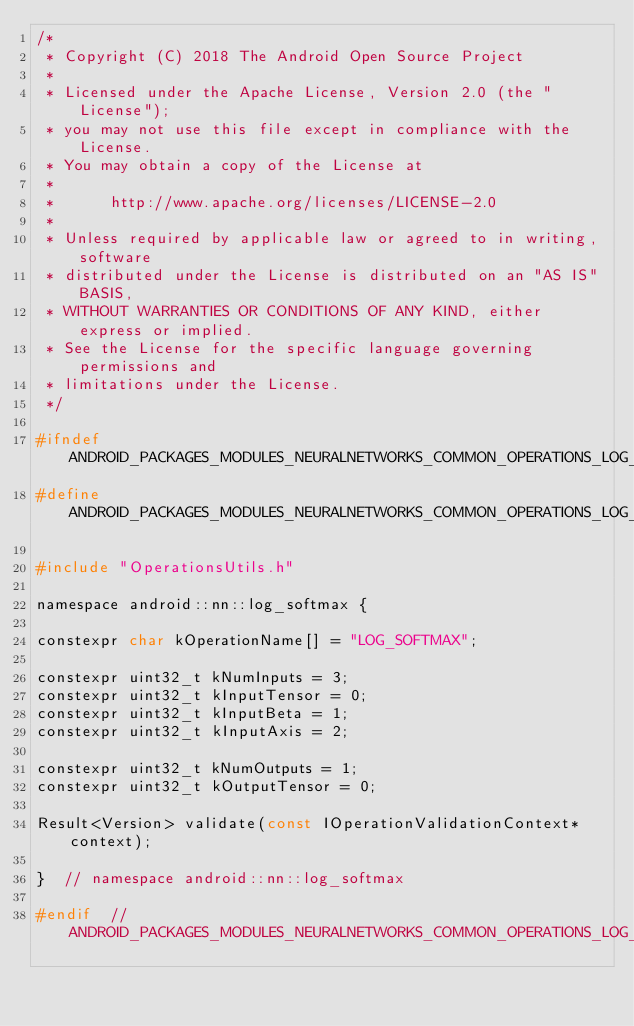Convert code to text. <code><loc_0><loc_0><loc_500><loc_500><_C_>/*
 * Copyright (C) 2018 The Android Open Source Project
 *
 * Licensed under the Apache License, Version 2.0 (the "License");
 * you may not use this file except in compliance with the License.
 * You may obtain a copy of the License at
 *
 *      http://www.apache.org/licenses/LICENSE-2.0
 *
 * Unless required by applicable law or agreed to in writing, software
 * distributed under the License is distributed on an "AS IS" BASIS,
 * WITHOUT WARRANTIES OR CONDITIONS OF ANY KIND, either express or implied.
 * See the License for the specific language governing permissions and
 * limitations under the License.
 */

#ifndef ANDROID_PACKAGES_MODULES_NEURALNETWORKS_COMMON_OPERATIONS_LOG_SOFTMAX_H
#define ANDROID_PACKAGES_MODULES_NEURALNETWORKS_COMMON_OPERATIONS_LOG_SOFTMAX_H

#include "OperationsUtils.h"

namespace android::nn::log_softmax {

constexpr char kOperationName[] = "LOG_SOFTMAX";

constexpr uint32_t kNumInputs = 3;
constexpr uint32_t kInputTensor = 0;
constexpr uint32_t kInputBeta = 1;
constexpr uint32_t kInputAxis = 2;

constexpr uint32_t kNumOutputs = 1;
constexpr uint32_t kOutputTensor = 0;

Result<Version> validate(const IOperationValidationContext* context);

}  // namespace android::nn::log_softmax

#endif  // ANDROID_PACKAGES_MODULES_NEURALNETWORKS_COMMON_OPERATIONS_LOG_SOFTMAX_H
</code> 